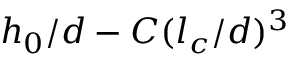Convert formula to latex. <formula><loc_0><loc_0><loc_500><loc_500>h _ { 0 } / d - C ( l _ { c } / d ) ^ { 3 }</formula> 